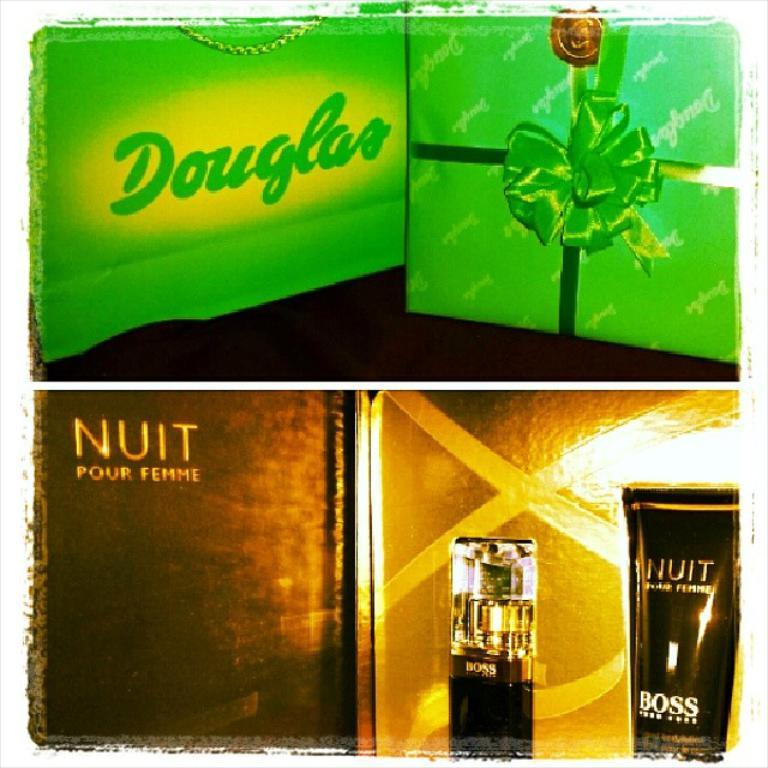<image>
Present a compact description of the photo's key features. Gift items from Douglas and Nuit pour Femme. 